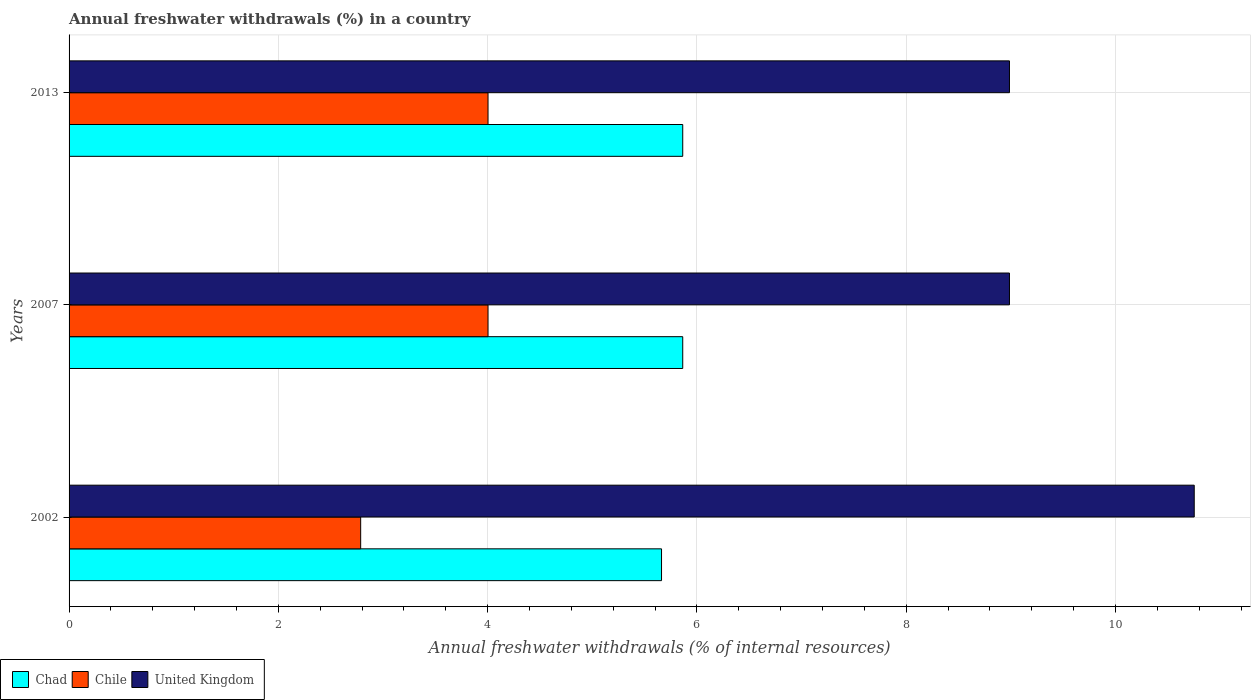Are the number of bars per tick equal to the number of legend labels?
Offer a terse response. Yes. How many bars are there on the 3rd tick from the bottom?
Offer a very short reply. 3. What is the label of the 3rd group of bars from the top?
Offer a terse response. 2002. In how many cases, is the number of bars for a given year not equal to the number of legend labels?
Your answer should be compact. 0. What is the percentage of annual freshwater withdrawals in Chad in 2002?
Give a very brief answer. 5.66. Across all years, what is the maximum percentage of annual freshwater withdrawals in Chad?
Give a very brief answer. 5.86. Across all years, what is the minimum percentage of annual freshwater withdrawals in Chad?
Give a very brief answer. 5.66. What is the total percentage of annual freshwater withdrawals in Chile in the graph?
Your answer should be very brief. 10.79. What is the difference between the percentage of annual freshwater withdrawals in Chad in 2013 and the percentage of annual freshwater withdrawals in United Kingdom in 2002?
Make the answer very short. -4.89. What is the average percentage of annual freshwater withdrawals in Chile per year?
Provide a succinct answer. 3.6. In the year 2002, what is the difference between the percentage of annual freshwater withdrawals in Chad and percentage of annual freshwater withdrawals in Chile?
Provide a succinct answer. 2.87. What is the ratio of the percentage of annual freshwater withdrawals in Chad in 2007 to that in 2013?
Offer a terse response. 1. Is the difference between the percentage of annual freshwater withdrawals in Chad in 2007 and 2013 greater than the difference between the percentage of annual freshwater withdrawals in Chile in 2007 and 2013?
Offer a very short reply. No. What is the difference between the highest and the second highest percentage of annual freshwater withdrawals in Chad?
Ensure brevity in your answer.  0. What is the difference between the highest and the lowest percentage of annual freshwater withdrawals in Chile?
Offer a terse response. 1.22. Is the sum of the percentage of annual freshwater withdrawals in Chad in 2002 and 2007 greater than the maximum percentage of annual freshwater withdrawals in Chile across all years?
Provide a short and direct response. Yes. What does the 3rd bar from the top in 2002 represents?
Offer a very short reply. Chad. Is it the case that in every year, the sum of the percentage of annual freshwater withdrawals in Chad and percentage of annual freshwater withdrawals in United Kingdom is greater than the percentage of annual freshwater withdrawals in Chile?
Provide a short and direct response. Yes. How many bars are there?
Ensure brevity in your answer.  9. Are the values on the major ticks of X-axis written in scientific E-notation?
Keep it short and to the point. No. Does the graph contain grids?
Provide a succinct answer. Yes. How many legend labels are there?
Your answer should be very brief. 3. How are the legend labels stacked?
Make the answer very short. Horizontal. What is the title of the graph?
Make the answer very short. Annual freshwater withdrawals (%) in a country. Does "Germany" appear as one of the legend labels in the graph?
Provide a short and direct response. No. What is the label or title of the X-axis?
Offer a very short reply. Annual freshwater withdrawals (% of internal resources). What is the label or title of the Y-axis?
Keep it short and to the point. Years. What is the Annual freshwater withdrawals (% of internal resources) in Chad in 2002?
Your response must be concise. 5.66. What is the Annual freshwater withdrawals (% of internal resources) of Chile in 2002?
Provide a succinct answer. 2.79. What is the Annual freshwater withdrawals (% of internal resources) in United Kingdom in 2002?
Your answer should be very brief. 10.75. What is the Annual freshwater withdrawals (% of internal resources) of Chad in 2007?
Your answer should be compact. 5.86. What is the Annual freshwater withdrawals (% of internal resources) in Chile in 2007?
Your answer should be very brief. 4. What is the Annual freshwater withdrawals (% of internal resources) of United Kingdom in 2007?
Provide a succinct answer. 8.99. What is the Annual freshwater withdrawals (% of internal resources) of Chad in 2013?
Your answer should be very brief. 5.86. What is the Annual freshwater withdrawals (% of internal resources) in Chile in 2013?
Your answer should be compact. 4. What is the Annual freshwater withdrawals (% of internal resources) of United Kingdom in 2013?
Keep it short and to the point. 8.99. Across all years, what is the maximum Annual freshwater withdrawals (% of internal resources) of Chad?
Your answer should be compact. 5.86. Across all years, what is the maximum Annual freshwater withdrawals (% of internal resources) in Chile?
Your answer should be very brief. 4. Across all years, what is the maximum Annual freshwater withdrawals (% of internal resources) of United Kingdom?
Your answer should be very brief. 10.75. Across all years, what is the minimum Annual freshwater withdrawals (% of internal resources) of Chad?
Your answer should be very brief. 5.66. Across all years, what is the minimum Annual freshwater withdrawals (% of internal resources) in Chile?
Provide a short and direct response. 2.79. Across all years, what is the minimum Annual freshwater withdrawals (% of internal resources) in United Kingdom?
Your answer should be very brief. 8.99. What is the total Annual freshwater withdrawals (% of internal resources) of Chad in the graph?
Keep it short and to the point. 17.39. What is the total Annual freshwater withdrawals (% of internal resources) of Chile in the graph?
Make the answer very short. 10.79. What is the total Annual freshwater withdrawals (% of internal resources) of United Kingdom in the graph?
Provide a succinct answer. 28.72. What is the difference between the Annual freshwater withdrawals (% of internal resources) of Chad in 2002 and that in 2007?
Give a very brief answer. -0.2. What is the difference between the Annual freshwater withdrawals (% of internal resources) in Chile in 2002 and that in 2007?
Provide a succinct answer. -1.22. What is the difference between the Annual freshwater withdrawals (% of internal resources) of United Kingdom in 2002 and that in 2007?
Make the answer very short. 1.77. What is the difference between the Annual freshwater withdrawals (% of internal resources) in Chad in 2002 and that in 2013?
Make the answer very short. -0.2. What is the difference between the Annual freshwater withdrawals (% of internal resources) in Chile in 2002 and that in 2013?
Provide a short and direct response. -1.22. What is the difference between the Annual freshwater withdrawals (% of internal resources) of United Kingdom in 2002 and that in 2013?
Offer a very short reply. 1.77. What is the difference between the Annual freshwater withdrawals (% of internal resources) of Chad in 2007 and that in 2013?
Your answer should be compact. 0. What is the difference between the Annual freshwater withdrawals (% of internal resources) of Chile in 2007 and that in 2013?
Make the answer very short. 0. What is the difference between the Annual freshwater withdrawals (% of internal resources) in United Kingdom in 2007 and that in 2013?
Give a very brief answer. 0. What is the difference between the Annual freshwater withdrawals (% of internal resources) in Chad in 2002 and the Annual freshwater withdrawals (% of internal resources) in Chile in 2007?
Keep it short and to the point. 1.66. What is the difference between the Annual freshwater withdrawals (% of internal resources) in Chad in 2002 and the Annual freshwater withdrawals (% of internal resources) in United Kingdom in 2007?
Provide a short and direct response. -3.32. What is the difference between the Annual freshwater withdrawals (% of internal resources) of Chile in 2002 and the Annual freshwater withdrawals (% of internal resources) of United Kingdom in 2007?
Your response must be concise. -6.2. What is the difference between the Annual freshwater withdrawals (% of internal resources) in Chad in 2002 and the Annual freshwater withdrawals (% of internal resources) in Chile in 2013?
Provide a succinct answer. 1.66. What is the difference between the Annual freshwater withdrawals (% of internal resources) of Chad in 2002 and the Annual freshwater withdrawals (% of internal resources) of United Kingdom in 2013?
Keep it short and to the point. -3.32. What is the difference between the Annual freshwater withdrawals (% of internal resources) in Chile in 2002 and the Annual freshwater withdrawals (% of internal resources) in United Kingdom in 2013?
Offer a terse response. -6.2. What is the difference between the Annual freshwater withdrawals (% of internal resources) in Chad in 2007 and the Annual freshwater withdrawals (% of internal resources) in Chile in 2013?
Keep it short and to the point. 1.86. What is the difference between the Annual freshwater withdrawals (% of internal resources) in Chad in 2007 and the Annual freshwater withdrawals (% of internal resources) in United Kingdom in 2013?
Provide a succinct answer. -3.12. What is the difference between the Annual freshwater withdrawals (% of internal resources) of Chile in 2007 and the Annual freshwater withdrawals (% of internal resources) of United Kingdom in 2013?
Your answer should be compact. -4.98. What is the average Annual freshwater withdrawals (% of internal resources) of Chad per year?
Give a very brief answer. 5.8. What is the average Annual freshwater withdrawals (% of internal resources) in Chile per year?
Your response must be concise. 3.6. What is the average Annual freshwater withdrawals (% of internal resources) in United Kingdom per year?
Offer a very short reply. 9.57. In the year 2002, what is the difference between the Annual freshwater withdrawals (% of internal resources) in Chad and Annual freshwater withdrawals (% of internal resources) in Chile?
Offer a terse response. 2.87. In the year 2002, what is the difference between the Annual freshwater withdrawals (% of internal resources) of Chad and Annual freshwater withdrawals (% of internal resources) of United Kingdom?
Provide a short and direct response. -5.09. In the year 2002, what is the difference between the Annual freshwater withdrawals (% of internal resources) of Chile and Annual freshwater withdrawals (% of internal resources) of United Kingdom?
Make the answer very short. -7.97. In the year 2007, what is the difference between the Annual freshwater withdrawals (% of internal resources) of Chad and Annual freshwater withdrawals (% of internal resources) of Chile?
Keep it short and to the point. 1.86. In the year 2007, what is the difference between the Annual freshwater withdrawals (% of internal resources) of Chad and Annual freshwater withdrawals (% of internal resources) of United Kingdom?
Ensure brevity in your answer.  -3.12. In the year 2007, what is the difference between the Annual freshwater withdrawals (% of internal resources) of Chile and Annual freshwater withdrawals (% of internal resources) of United Kingdom?
Provide a succinct answer. -4.98. In the year 2013, what is the difference between the Annual freshwater withdrawals (% of internal resources) of Chad and Annual freshwater withdrawals (% of internal resources) of Chile?
Your answer should be very brief. 1.86. In the year 2013, what is the difference between the Annual freshwater withdrawals (% of internal resources) of Chad and Annual freshwater withdrawals (% of internal resources) of United Kingdom?
Offer a terse response. -3.12. In the year 2013, what is the difference between the Annual freshwater withdrawals (% of internal resources) in Chile and Annual freshwater withdrawals (% of internal resources) in United Kingdom?
Give a very brief answer. -4.98. What is the ratio of the Annual freshwater withdrawals (% of internal resources) in Chad in 2002 to that in 2007?
Provide a short and direct response. 0.97. What is the ratio of the Annual freshwater withdrawals (% of internal resources) of Chile in 2002 to that in 2007?
Provide a short and direct response. 0.7. What is the ratio of the Annual freshwater withdrawals (% of internal resources) of United Kingdom in 2002 to that in 2007?
Offer a terse response. 1.2. What is the ratio of the Annual freshwater withdrawals (% of internal resources) in Chad in 2002 to that in 2013?
Your response must be concise. 0.97. What is the ratio of the Annual freshwater withdrawals (% of internal resources) of Chile in 2002 to that in 2013?
Keep it short and to the point. 0.7. What is the ratio of the Annual freshwater withdrawals (% of internal resources) of United Kingdom in 2002 to that in 2013?
Your answer should be very brief. 1.2. What is the ratio of the Annual freshwater withdrawals (% of internal resources) in Chad in 2007 to that in 2013?
Your answer should be compact. 1. What is the ratio of the Annual freshwater withdrawals (% of internal resources) in Chile in 2007 to that in 2013?
Offer a very short reply. 1. What is the ratio of the Annual freshwater withdrawals (% of internal resources) of United Kingdom in 2007 to that in 2013?
Give a very brief answer. 1. What is the difference between the highest and the second highest Annual freshwater withdrawals (% of internal resources) of Chad?
Make the answer very short. 0. What is the difference between the highest and the second highest Annual freshwater withdrawals (% of internal resources) of Chile?
Make the answer very short. 0. What is the difference between the highest and the second highest Annual freshwater withdrawals (% of internal resources) in United Kingdom?
Offer a terse response. 1.77. What is the difference between the highest and the lowest Annual freshwater withdrawals (% of internal resources) of Chad?
Your response must be concise. 0.2. What is the difference between the highest and the lowest Annual freshwater withdrawals (% of internal resources) in Chile?
Provide a succinct answer. 1.22. What is the difference between the highest and the lowest Annual freshwater withdrawals (% of internal resources) of United Kingdom?
Your answer should be compact. 1.77. 